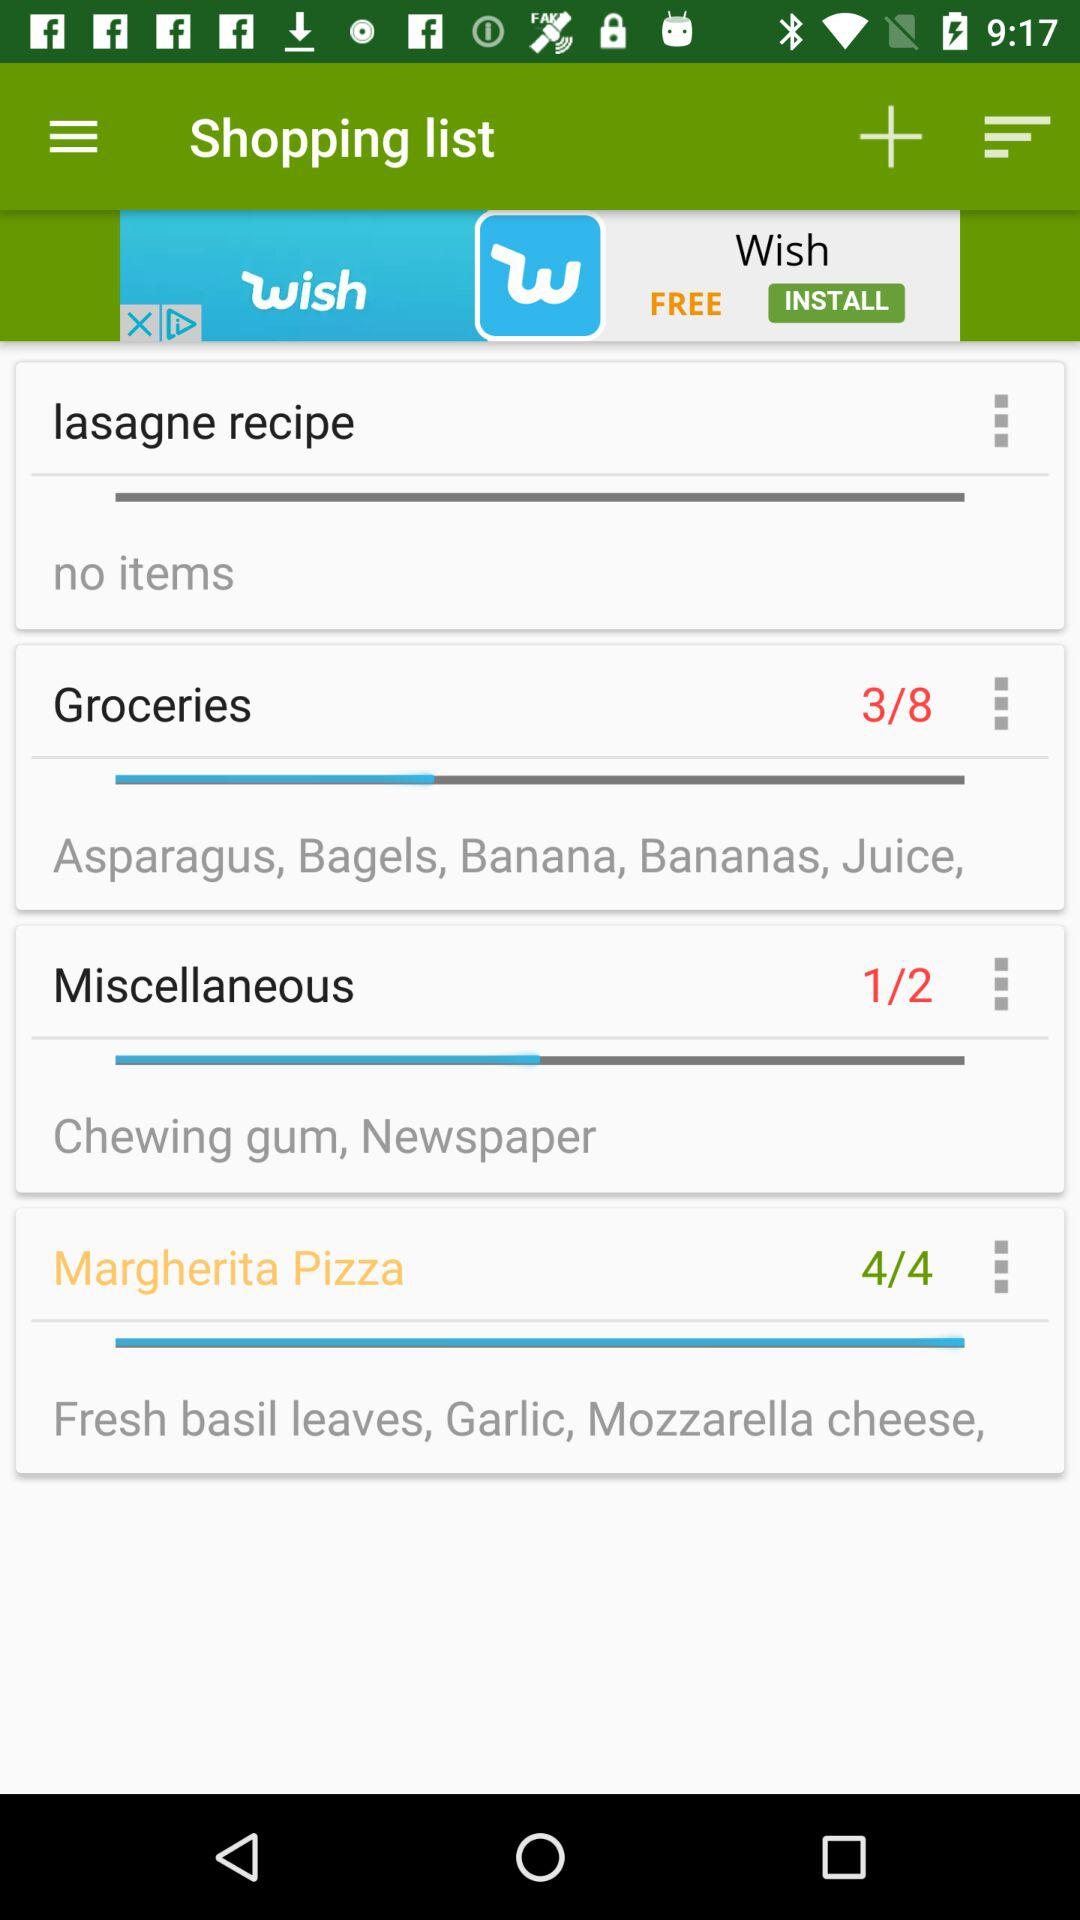What are the items in groceries? The items in groceries are "Asparagus", "Bagels", "Banana", "Bananas" and "Juice". 